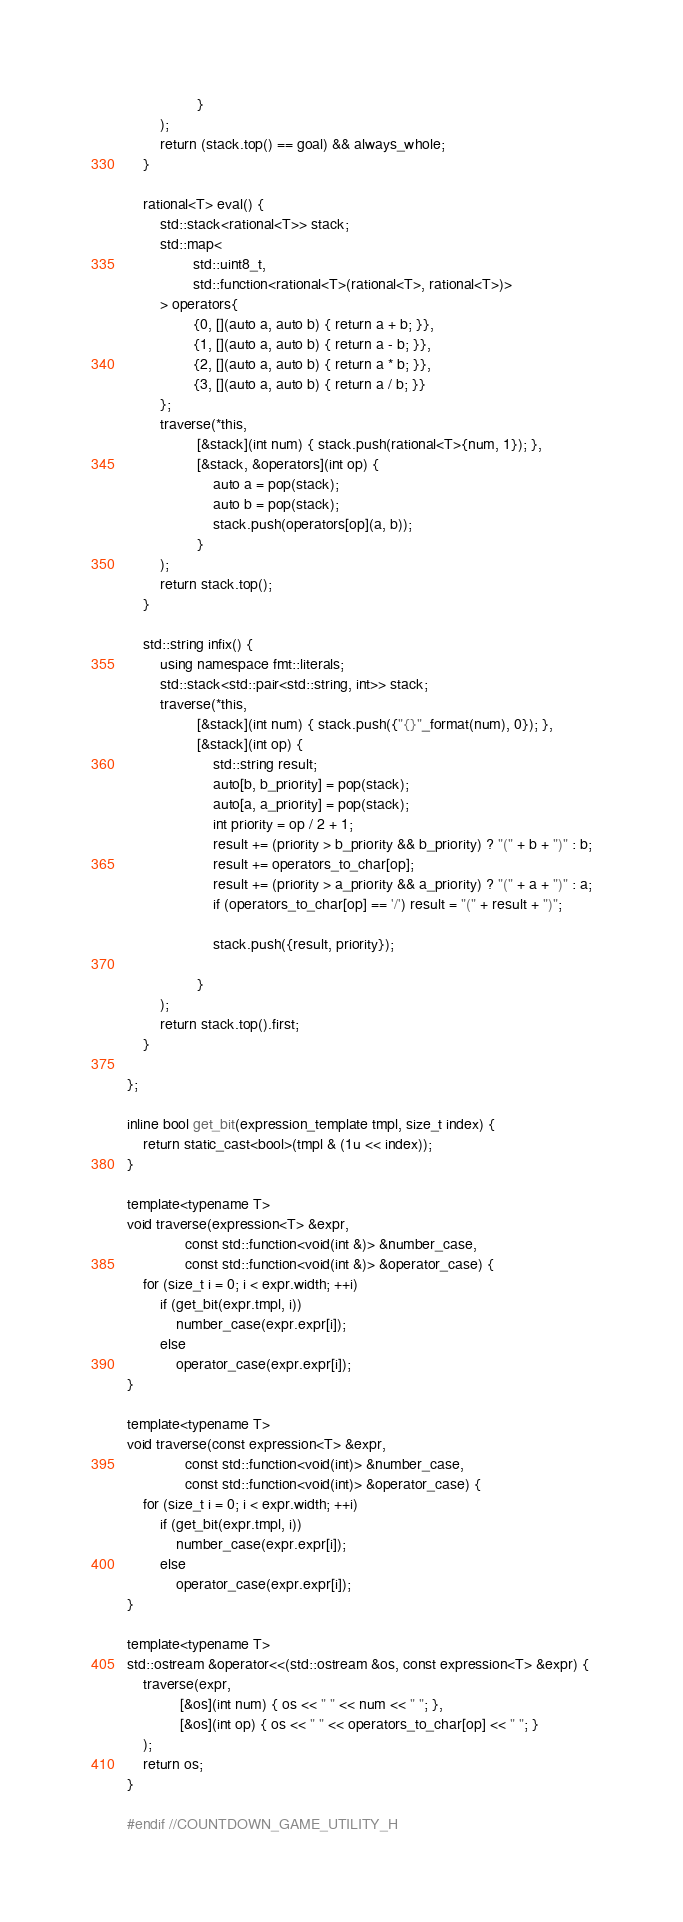Convert code to text. <code><loc_0><loc_0><loc_500><loc_500><_C_>                 }
        );
        return (stack.top() == goal) && always_whole;
    }

    rational<T> eval() {
        std::stack<rational<T>> stack;
        std::map<
                std::uint8_t,
                std::function<rational<T>(rational<T>, rational<T>)>
        > operators{
                {0, [](auto a, auto b) { return a + b; }},
                {1, [](auto a, auto b) { return a - b; }},
                {2, [](auto a, auto b) { return a * b; }},
                {3, [](auto a, auto b) { return a / b; }}
        };
        traverse(*this,
                 [&stack](int num) { stack.push(rational<T>{num, 1}); },
                 [&stack, &operators](int op) {
                     auto a = pop(stack);
                     auto b = pop(stack);
                     stack.push(operators[op](a, b));
                 }
        );
        return stack.top();
    }

    std::string infix() {
        using namespace fmt::literals;
        std::stack<std::pair<std::string, int>> stack;
        traverse(*this,
                 [&stack](int num) { stack.push({"{}"_format(num), 0}); },
                 [&stack](int op) {
                     std::string result;
                     auto[b, b_priority] = pop(stack);
                     auto[a, a_priority] = pop(stack);
                     int priority = op / 2 + 1;
                     result += (priority > b_priority && b_priority) ? "(" + b + ")" : b;
                     result += operators_to_char[op];
                     result += (priority > a_priority && a_priority) ? "(" + a + ")" : a;
                     if (operators_to_char[op] == '/') result = "(" + result + ")";

                     stack.push({result, priority});

                 }
        );
        return stack.top().first;
    }

};

inline bool get_bit(expression_template tmpl, size_t index) {
    return static_cast<bool>(tmpl & (1u << index));
}

template<typename T>
void traverse(expression<T> &expr,
              const std::function<void(int &)> &number_case,
              const std::function<void(int &)> &operator_case) {
    for (size_t i = 0; i < expr.width; ++i)
        if (get_bit(expr.tmpl, i))
            number_case(expr.expr[i]);
        else
            operator_case(expr.expr[i]);
}

template<typename T>
void traverse(const expression<T> &expr,
              const std::function<void(int)> &number_case,
              const std::function<void(int)> &operator_case) {
    for (size_t i = 0; i < expr.width; ++i)
        if (get_bit(expr.tmpl, i))
            number_case(expr.expr[i]);
        else
            operator_case(expr.expr[i]);
}

template<typename T>
std::ostream &operator<<(std::ostream &os, const expression<T> &expr) {
    traverse(expr,
             [&os](int num) { os << " " << num << " "; },
             [&os](int op) { os << " " << operators_to_char[op] << " "; }
    );
    return os;
}

#endif //COUNTDOWN_GAME_UTILITY_H
</code> 